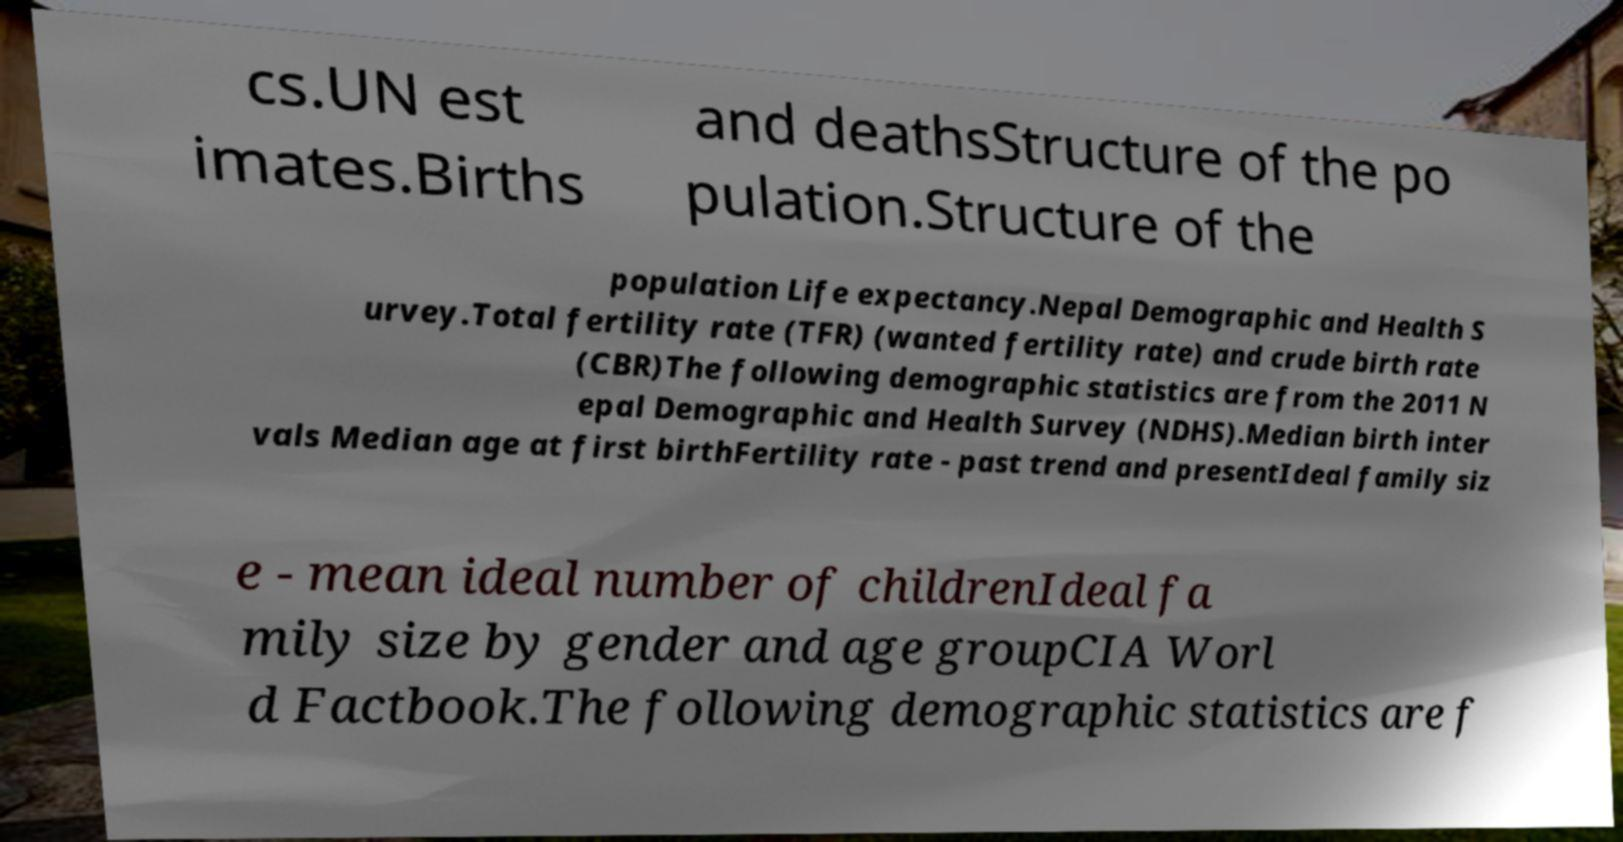Could you assist in decoding the text presented in this image and type it out clearly? cs.UN est imates.Births and deathsStructure of the po pulation.Structure of the population Life expectancy.Nepal Demographic and Health S urvey.Total fertility rate (TFR) (wanted fertility rate) and crude birth rate (CBR)The following demographic statistics are from the 2011 N epal Demographic and Health Survey (NDHS).Median birth inter vals Median age at first birthFertility rate - past trend and presentIdeal family siz e - mean ideal number of childrenIdeal fa mily size by gender and age groupCIA Worl d Factbook.The following demographic statistics are f 